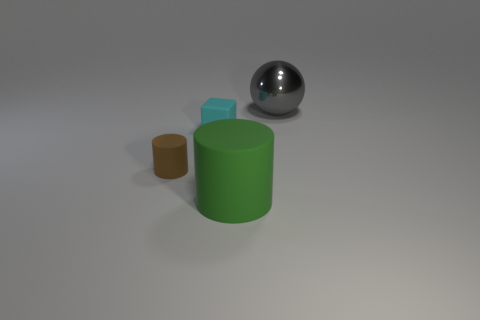There is a thing on the right side of the green cylinder; does it have the same shape as the cyan thing?
Your answer should be very brief. No. There is a large object that is behind the big thing that is on the left side of the big object behind the cyan rubber object; what shape is it?
Provide a short and direct response. Sphere. What size is the gray shiny sphere?
Offer a terse response. Large. The cube that is the same material as the small cylinder is what color?
Provide a succinct answer. Cyan. How many brown things have the same material as the gray object?
Offer a very short reply. 0. Is the color of the large metal ball the same as the small matte cube right of the tiny brown cylinder?
Keep it short and to the point. No. The cylinder that is to the left of the big object that is in front of the brown matte object is what color?
Your answer should be compact. Brown. There is a cube that is the same size as the brown rubber cylinder; what is its color?
Provide a succinct answer. Cyan. Is there a green object that has the same shape as the tiny brown thing?
Your answer should be compact. Yes. What shape is the cyan object?
Your response must be concise. Cube. 